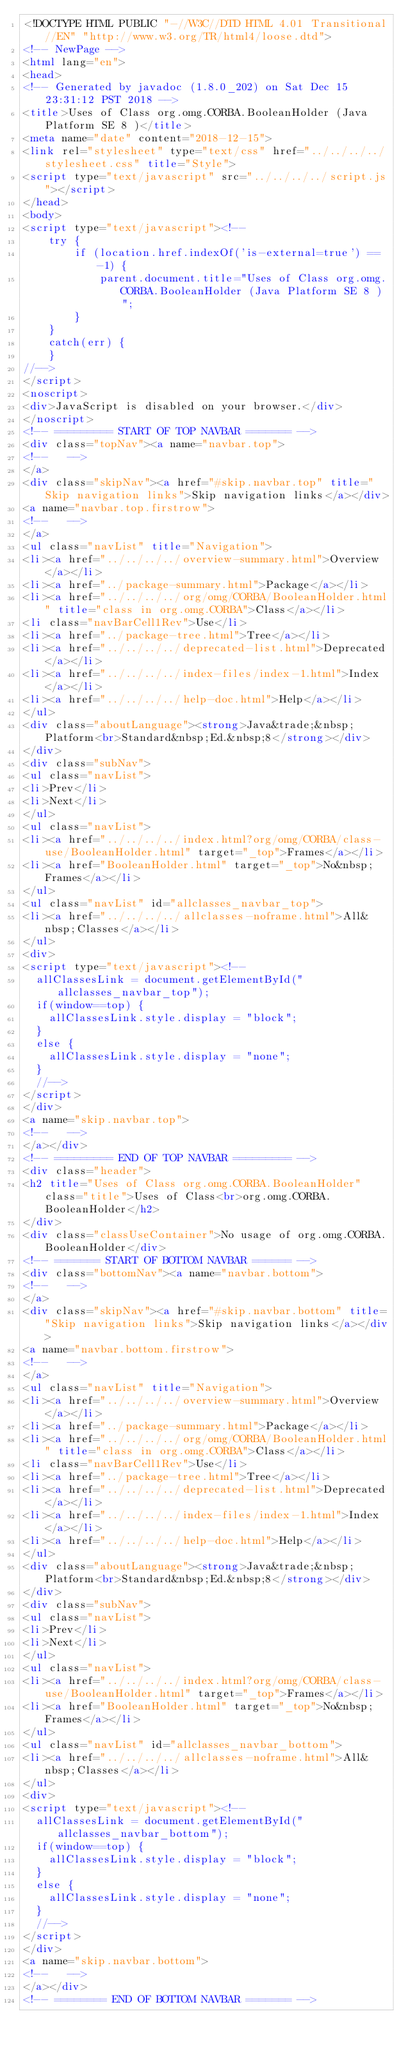<code> <loc_0><loc_0><loc_500><loc_500><_HTML_><!DOCTYPE HTML PUBLIC "-//W3C//DTD HTML 4.01 Transitional//EN" "http://www.w3.org/TR/html4/loose.dtd">
<!-- NewPage -->
<html lang="en">
<head>
<!-- Generated by javadoc (1.8.0_202) on Sat Dec 15 23:31:12 PST 2018 -->
<title>Uses of Class org.omg.CORBA.BooleanHolder (Java Platform SE 8 )</title>
<meta name="date" content="2018-12-15">
<link rel="stylesheet" type="text/css" href="../../../../stylesheet.css" title="Style">
<script type="text/javascript" src="../../../../script.js"></script>
</head>
<body>
<script type="text/javascript"><!--
    try {
        if (location.href.indexOf('is-external=true') == -1) {
            parent.document.title="Uses of Class org.omg.CORBA.BooleanHolder (Java Platform SE 8 )";
        }
    }
    catch(err) {
    }
//-->
</script>
<noscript>
<div>JavaScript is disabled on your browser.</div>
</noscript>
<!-- ========= START OF TOP NAVBAR ======= -->
<div class="topNav"><a name="navbar.top">
<!--   -->
</a>
<div class="skipNav"><a href="#skip.navbar.top" title="Skip navigation links">Skip navigation links</a></div>
<a name="navbar.top.firstrow">
<!--   -->
</a>
<ul class="navList" title="Navigation">
<li><a href="../../../../overview-summary.html">Overview</a></li>
<li><a href="../package-summary.html">Package</a></li>
<li><a href="../../../../org/omg/CORBA/BooleanHolder.html" title="class in org.omg.CORBA">Class</a></li>
<li class="navBarCell1Rev">Use</li>
<li><a href="../package-tree.html">Tree</a></li>
<li><a href="../../../../deprecated-list.html">Deprecated</a></li>
<li><a href="../../../../index-files/index-1.html">Index</a></li>
<li><a href="../../../../help-doc.html">Help</a></li>
</ul>
<div class="aboutLanguage"><strong>Java&trade;&nbsp;Platform<br>Standard&nbsp;Ed.&nbsp;8</strong></div>
</div>
<div class="subNav">
<ul class="navList">
<li>Prev</li>
<li>Next</li>
</ul>
<ul class="navList">
<li><a href="../../../../index.html?org/omg/CORBA/class-use/BooleanHolder.html" target="_top">Frames</a></li>
<li><a href="BooleanHolder.html" target="_top">No&nbsp;Frames</a></li>
</ul>
<ul class="navList" id="allclasses_navbar_top">
<li><a href="../../../../allclasses-noframe.html">All&nbsp;Classes</a></li>
</ul>
<div>
<script type="text/javascript"><!--
  allClassesLink = document.getElementById("allclasses_navbar_top");
  if(window==top) {
    allClassesLink.style.display = "block";
  }
  else {
    allClassesLink.style.display = "none";
  }
  //-->
</script>
</div>
<a name="skip.navbar.top">
<!--   -->
</a></div>
<!-- ========= END OF TOP NAVBAR ========= -->
<div class="header">
<h2 title="Uses of Class org.omg.CORBA.BooleanHolder" class="title">Uses of Class<br>org.omg.CORBA.BooleanHolder</h2>
</div>
<div class="classUseContainer">No usage of org.omg.CORBA.BooleanHolder</div>
<!-- ======= START OF BOTTOM NAVBAR ====== -->
<div class="bottomNav"><a name="navbar.bottom">
<!--   -->
</a>
<div class="skipNav"><a href="#skip.navbar.bottom" title="Skip navigation links">Skip navigation links</a></div>
<a name="navbar.bottom.firstrow">
<!--   -->
</a>
<ul class="navList" title="Navigation">
<li><a href="../../../../overview-summary.html">Overview</a></li>
<li><a href="../package-summary.html">Package</a></li>
<li><a href="../../../../org/omg/CORBA/BooleanHolder.html" title="class in org.omg.CORBA">Class</a></li>
<li class="navBarCell1Rev">Use</li>
<li><a href="../package-tree.html">Tree</a></li>
<li><a href="../../../../deprecated-list.html">Deprecated</a></li>
<li><a href="../../../../index-files/index-1.html">Index</a></li>
<li><a href="../../../../help-doc.html">Help</a></li>
</ul>
<div class="aboutLanguage"><strong>Java&trade;&nbsp;Platform<br>Standard&nbsp;Ed.&nbsp;8</strong></div>
</div>
<div class="subNav">
<ul class="navList">
<li>Prev</li>
<li>Next</li>
</ul>
<ul class="navList">
<li><a href="../../../../index.html?org/omg/CORBA/class-use/BooleanHolder.html" target="_top">Frames</a></li>
<li><a href="BooleanHolder.html" target="_top">No&nbsp;Frames</a></li>
</ul>
<ul class="navList" id="allclasses_navbar_bottom">
<li><a href="../../../../allclasses-noframe.html">All&nbsp;Classes</a></li>
</ul>
<div>
<script type="text/javascript"><!--
  allClassesLink = document.getElementById("allclasses_navbar_bottom");
  if(window==top) {
    allClassesLink.style.display = "block";
  }
  else {
    allClassesLink.style.display = "none";
  }
  //-->
</script>
</div>
<a name="skip.navbar.bottom">
<!--   -->
</a></div>
<!-- ======== END OF BOTTOM NAVBAR ======= --></code> 